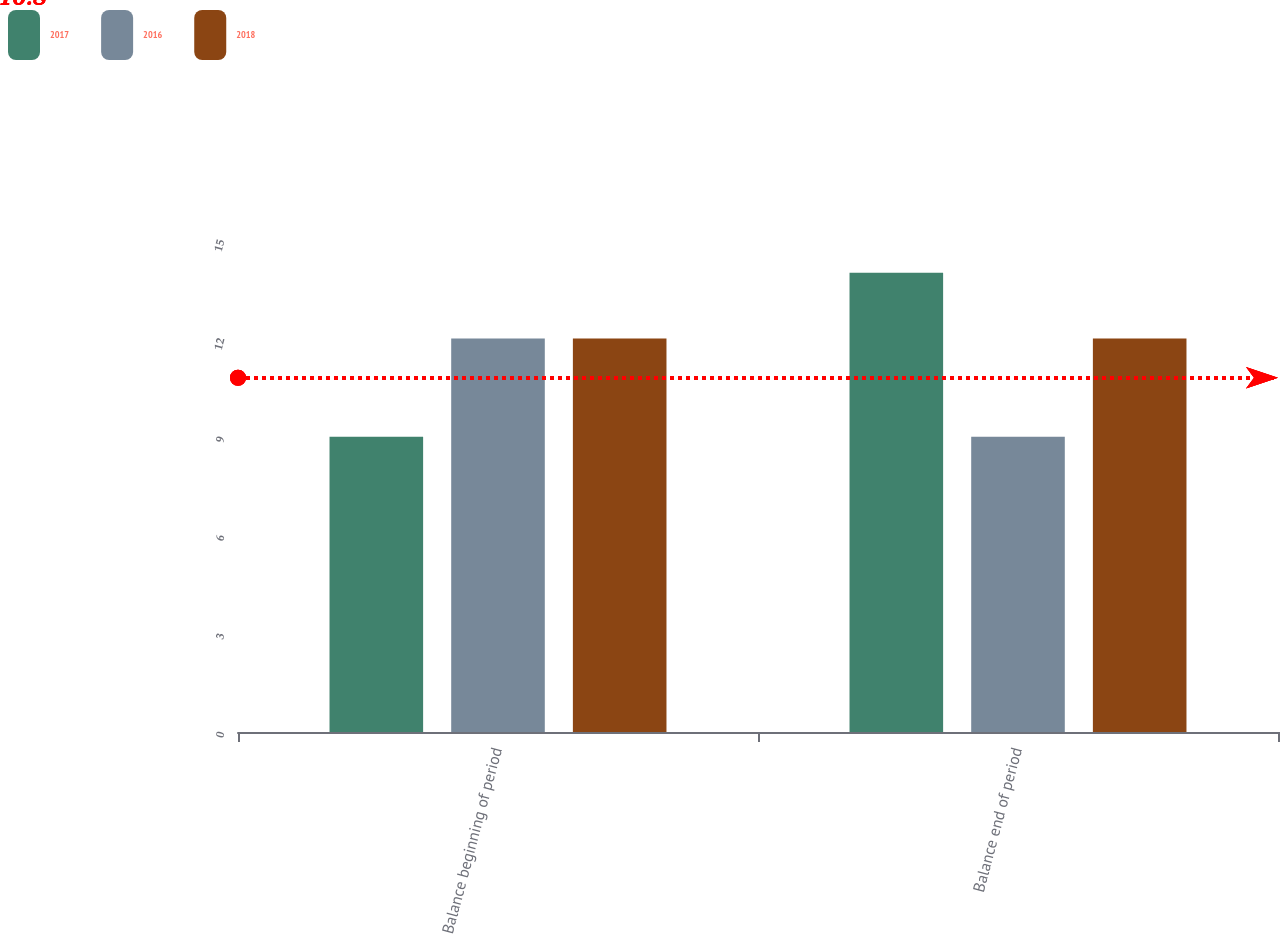Convert chart. <chart><loc_0><loc_0><loc_500><loc_500><stacked_bar_chart><ecel><fcel>Balance beginning of period<fcel>Balance end of period<nl><fcel>2017<fcel>9<fcel>14<nl><fcel>2016<fcel>12<fcel>9<nl><fcel>2018<fcel>12<fcel>12<nl></chart> 